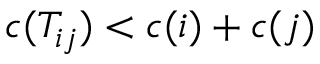<formula> <loc_0><loc_0><loc_500><loc_500>c ( T _ { i j } ) < c ( i ) + c ( j )</formula> 